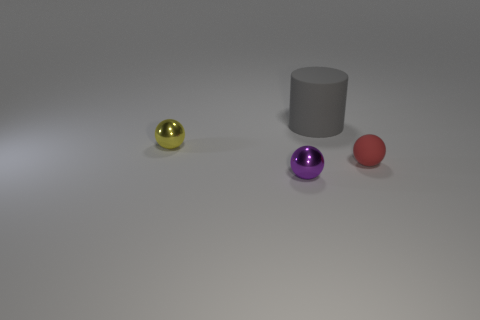Can you describe the atmosphere or mood that this image conveys? The image has a minimalist and sterile aesthetic that conveys a sense of calmness and simplicity. The smooth textures, soft lighting, and sparse arrangement give the scene a tranquil, almost gallery-like mood. 